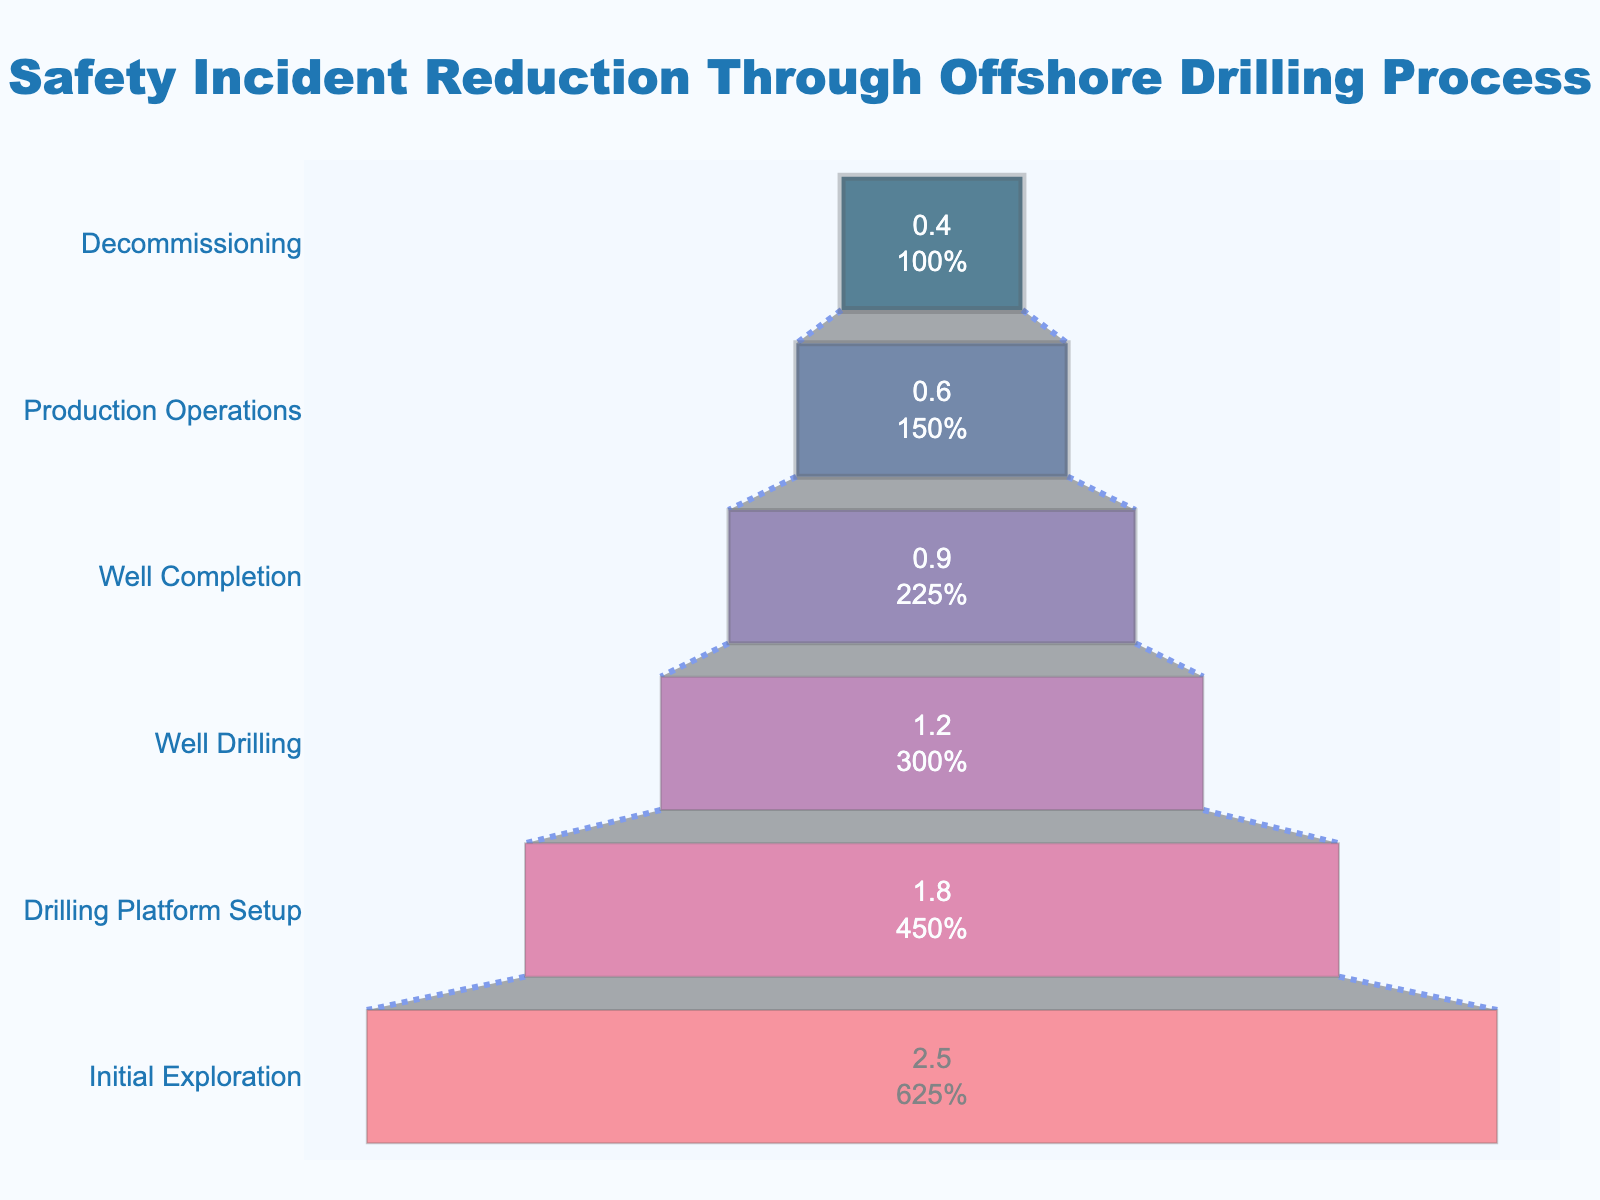Which stage has the highest incident rate? The highest bar represents the stage with the highest incident rate. From the chart, the "Initial Exploration" stage has the tallest bar.
Answer: Initial Exploration What is the title of the figure? The title is centered at the top of the figure and clearly labeled.
Answer: Safety Incident Reduction Through Offshore Drilling Process By how much does the incident rate decrease from the Initial Exploration stage to the Well Drilling stage? Subtract the incident rate of the Well Drilling stage (1.2) from the Initial Exploration stage (2.5). The decrease is 2.5 - 1.2 = 1.3.
Answer: 1.3 Which stage shows fewer incidents, Drilling Platform Setup or Production Operations? Compare the heights of the bars for these two stages. Drilling Platform Setup has incidents of 1.8 and Production Operations has incidents of 0.6.
Answer: Production Operations What is the incident rate during the Decommissioning stage? Look for the bar that represents the Decommissioning stage and check its value.
Answer: 0.4 How many stages are listed in the funnel chart? Count the number of unique stages listed on the y-axis of the figure.
Answer: 6 What percentage of the initial incidents occurs during the Well Completion stage? The figure shows each stage both as an absolute value and as a percentage of the initial value. For Well Completion, it shows the percentage directly.
Answer: 36% What is the average incident rate across all stages? Sum all incident rates (2.5 + 1.8 + 1.2 + 0.9 + 0.6 + 0.4) and divide by the number of stages (6). The average is (2.5 + 1.8 + 1.2 + 0.9 + 0.6 + 0.4) / 6 = 1.23.
Answer: 1.23 Which stage shows the greatest reduction in incidents compared to the previous stage? Calculate the reductions between consecutive stages: Initial Exploration to Drilling Platform Setup (2.5 - 1.8 = 0.7), Drilling Platform Setup to Well Drilling (1.8 - 1.2 = 0.6), Well Drilling to Well Completion (1.2 - 0.9 = 0.3), Well Completion to Production Operations (0.9 - 0.6 = 0.3), Production Operations to Decommissioning (0.6 - 0.4 = 0.2). The greatest reduction (0.7) occurs between Initial Exploration and Drilling Platform Setup.
Answer: Initial Exploration to Drilling Platform Setup 